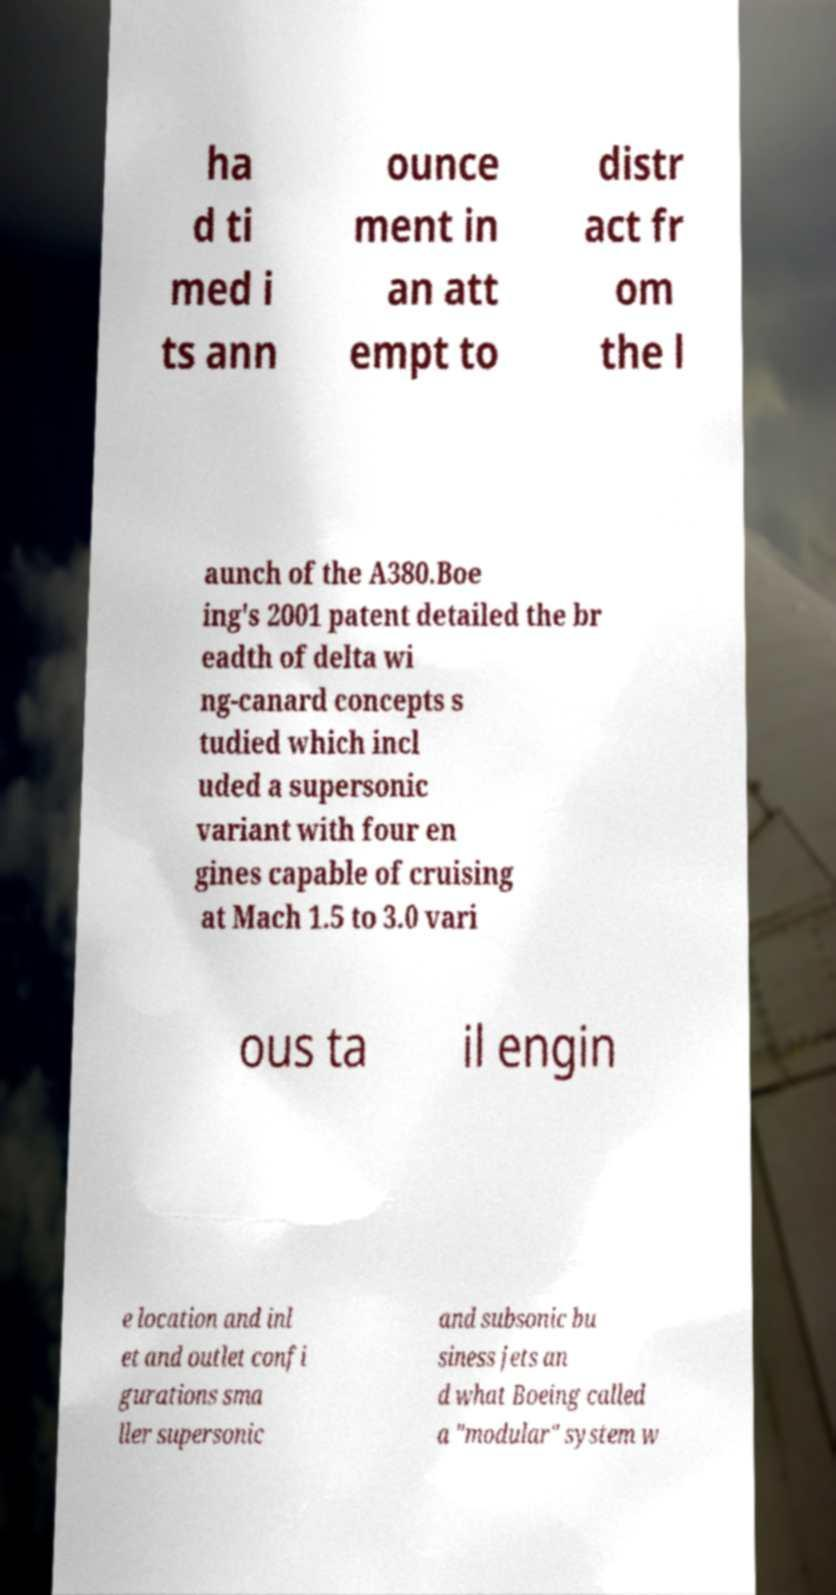Can you accurately transcribe the text from the provided image for me? ha d ti med i ts ann ounce ment in an att empt to distr act fr om the l aunch of the A380.Boe ing's 2001 patent detailed the br eadth of delta wi ng-canard concepts s tudied which incl uded a supersonic variant with four en gines capable of cruising at Mach 1.5 to 3.0 vari ous ta il engin e location and inl et and outlet confi gurations sma ller supersonic and subsonic bu siness jets an d what Boeing called a "modular" system w 